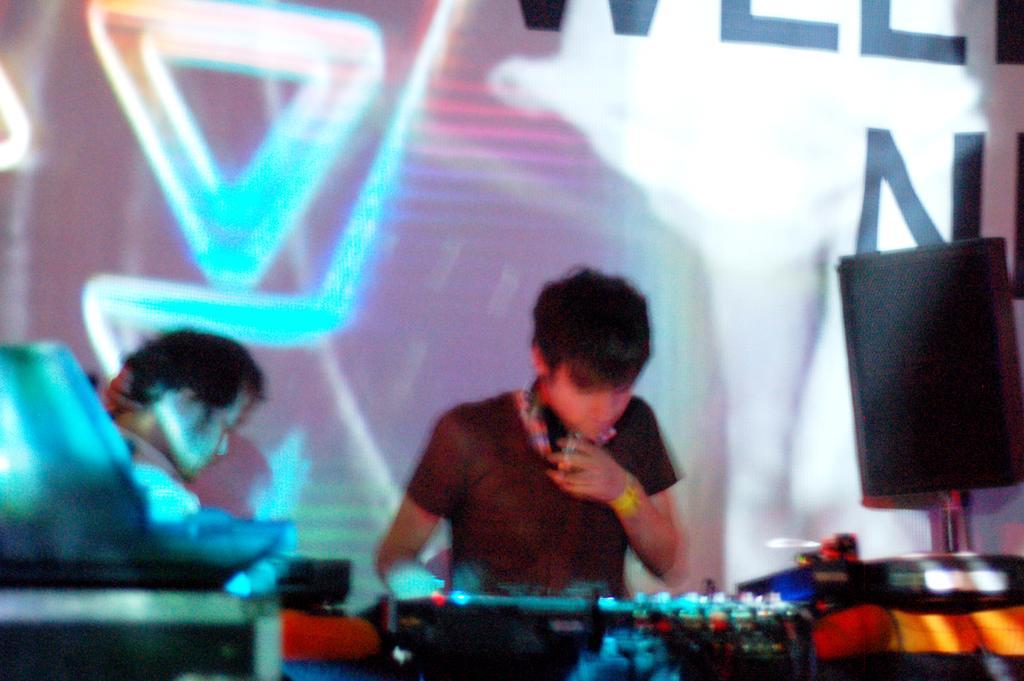Please provide a concise description of this image. In this image I can see a few people standing and playing musical instruments behind them there is a banner on the wall and speaker to the pole. 